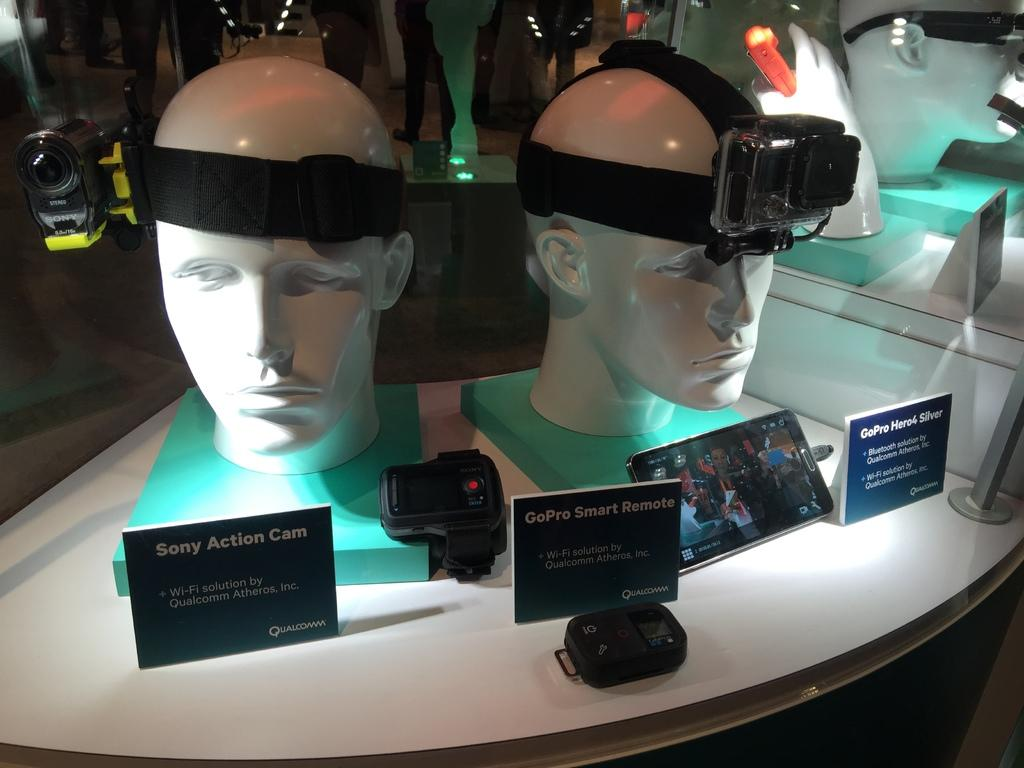What type of objects are present on the mannequin heads in the image? The mannequin heads in the image have unspecified objects on them. What part of a person can be seen in the image? There is a hand visible in the image. What type of equipment is present in the image? There are cameras in the image. What type of flat surfaces are present in the image? There are boards in the image. What other objects can be seen in the image that are not specified? There are other unspecified objects in the image. What is behind the mannequin heads in the image? There is a glass behind the mannequin heads. What type of stem can be seen growing from the vegetable in the image? There is no vegetable or stem present in the image. How does the image compare to a similar image of a different scene? The image cannot be compared to a similar image of a different scene, as we do not have any other images to make a comparison. 